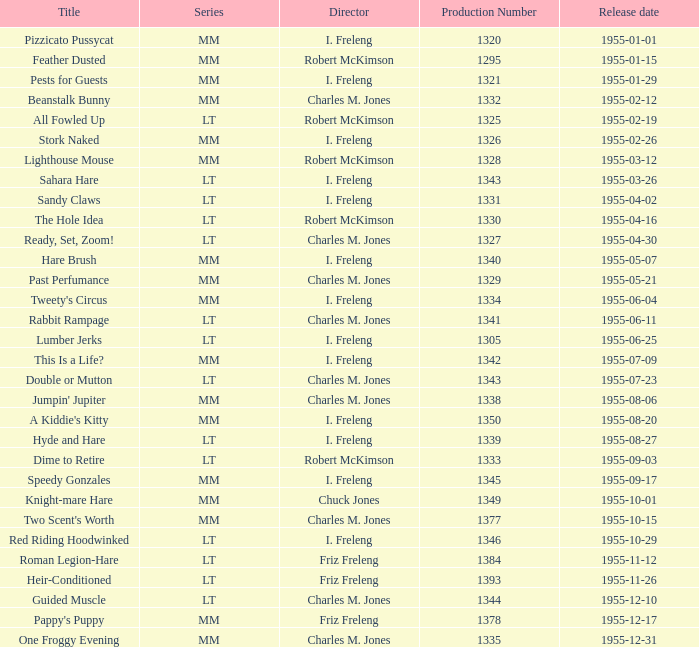Which release had the greatest production number on april 2, 1955, under the direction of i. freleng? 1331.0. 